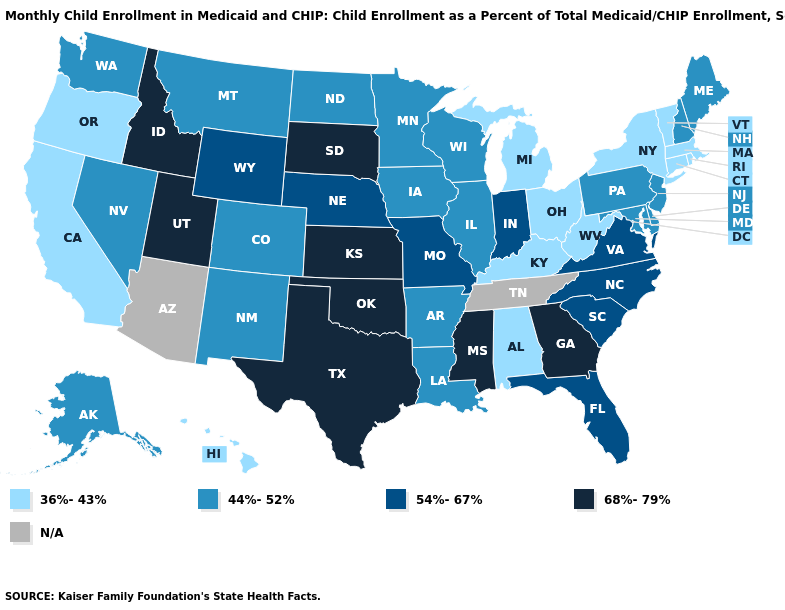What is the value of Alaska?
Be succinct. 44%-52%. Which states have the highest value in the USA?
Write a very short answer. Georgia, Idaho, Kansas, Mississippi, Oklahoma, South Dakota, Texas, Utah. What is the value of Massachusetts?
Be succinct. 36%-43%. Does Washington have the lowest value in the USA?
Be succinct. No. Which states have the highest value in the USA?
Keep it brief. Georgia, Idaho, Kansas, Mississippi, Oklahoma, South Dakota, Texas, Utah. Does the first symbol in the legend represent the smallest category?
Give a very brief answer. Yes. Name the states that have a value in the range 68%-79%?
Give a very brief answer. Georgia, Idaho, Kansas, Mississippi, Oklahoma, South Dakota, Texas, Utah. What is the value of Arizona?
Give a very brief answer. N/A. Does the map have missing data?
Give a very brief answer. Yes. Among the states that border Texas , which have the highest value?
Keep it brief. Oklahoma. Among the states that border Illinois , does Iowa have the lowest value?
Give a very brief answer. No. Does Delaware have the highest value in the USA?
Be succinct. No. Which states have the lowest value in the USA?
Give a very brief answer. Alabama, California, Connecticut, Hawaii, Kentucky, Massachusetts, Michigan, New York, Ohio, Oregon, Rhode Island, Vermont, West Virginia. What is the lowest value in the South?
Quick response, please. 36%-43%. 